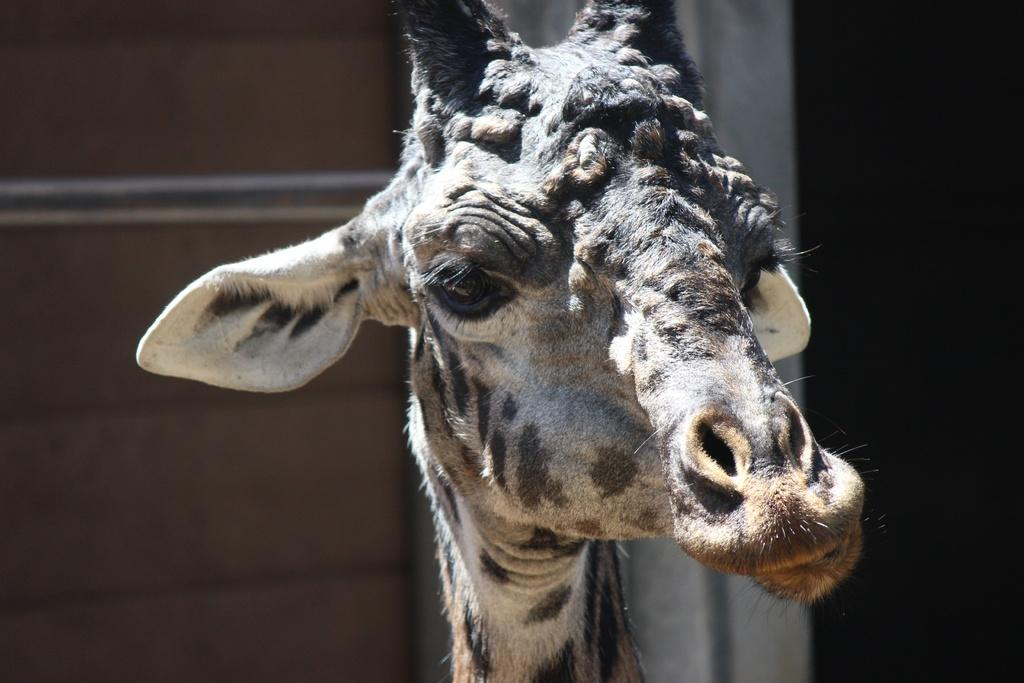What animal is in the foreground of the image? There is a giraffe in the foreground of the image. What type of objects can be seen in the background of the image? There are metal rods and a wall-like object in the background of the image. What type of beans are being harvested in the image? There are no beans present in the image; it features a giraffe in the foreground and metal rods and a wall-like object in the background. 